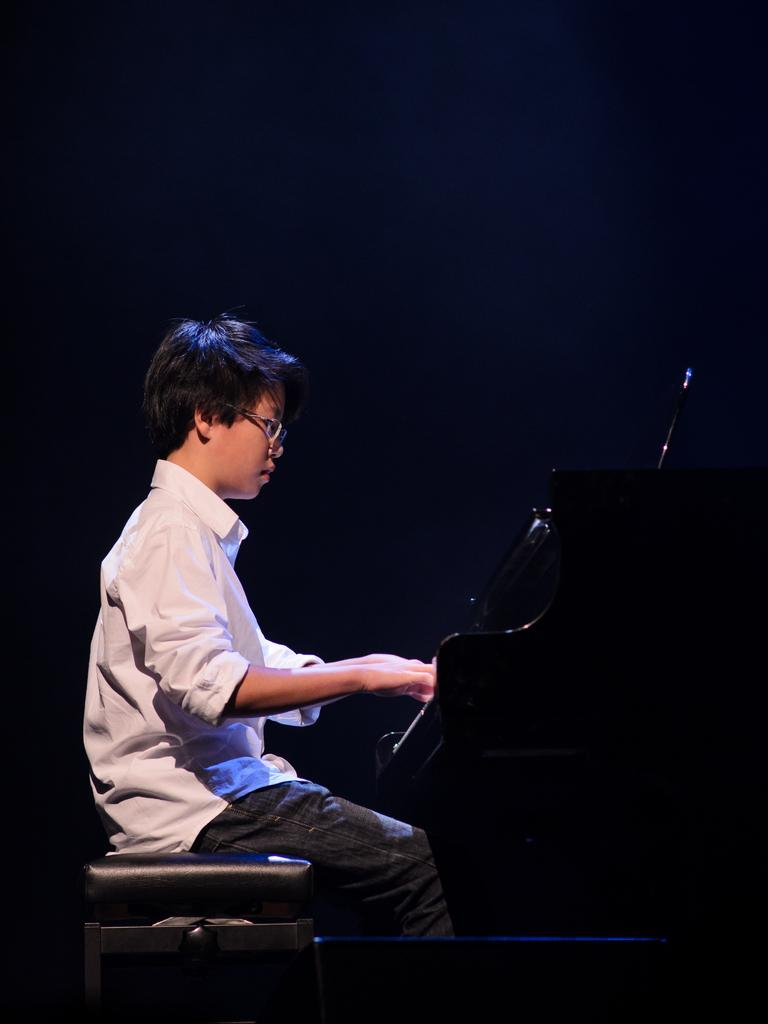What is the main subject of the image? The main subject of the image is a kid. What is the kid wearing? The kid is wearing clothes. What is the kid sitting on? The kid is sitting on a stool. What can be seen on the right side of the image? There is a piano on the right side of the image. How much did the organization pay for the cent in the image? There is no cent or organization present in the image. 